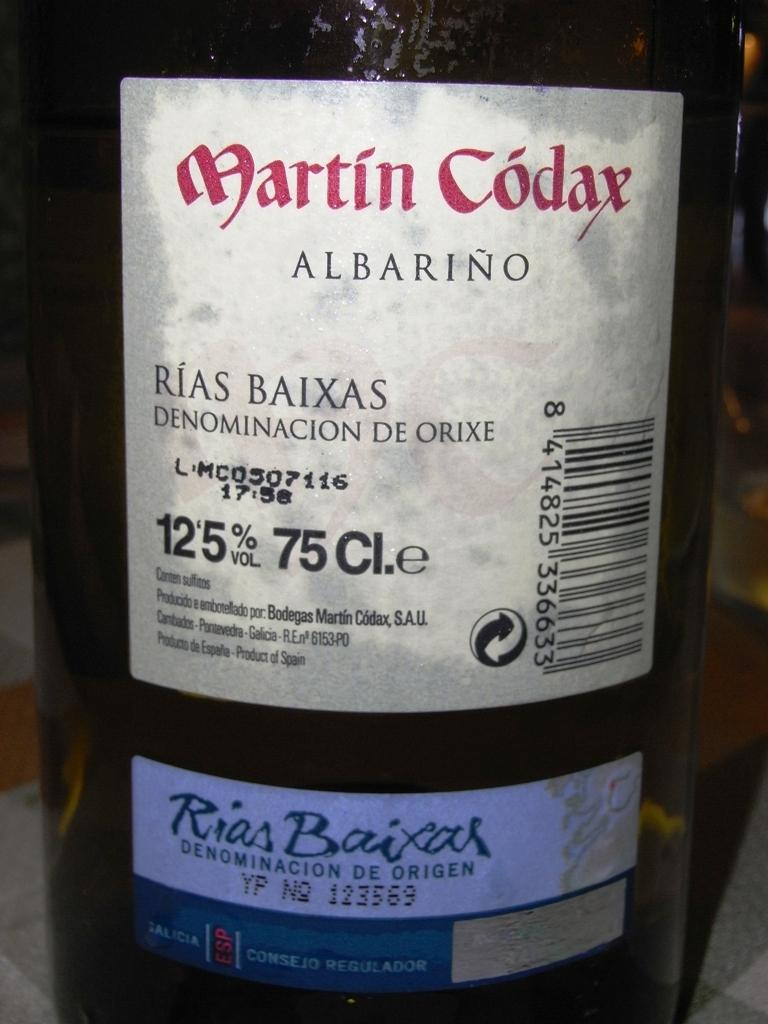<image>
Describe the image concisely. A Martin Codax label says it is 12.5% by volume. 